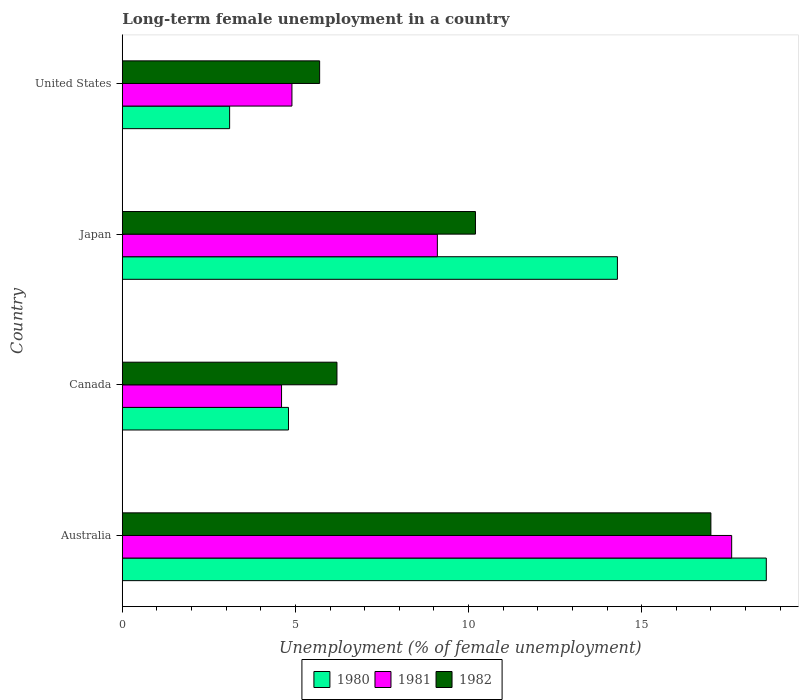How many different coloured bars are there?
Provide a succinct answer. 3. Are the number of bars per tick equal to the number of legend labels?
Ensure brevity in your answer.  Yes. How many bars are there on the 1st tick from the top?
Your response must be concise. 3. What is the label of the 4th group of bars from the top?
Provide a succinct answer. Australia. What is the percentage of long-term unemployed female population in 1980 in United States?
Your answer should be compact. 3.1. Across all countries, what is the maximum percentage of long-term unemployed female population in 1980?
Your answer should be compact. 18.6. Across all countries, what is the minimum percentage of long-term unemployed female population in 1982?
Your response must be concise. 5.7. What is the total percentage of long-term unemployed female population in 1981 in the graph?
Your response must be concise. 36.2. What is the difference between the percentage of long-term unemployed female population in 1980 in Japan and that in United States?
Keep it short and to the point. 11.2. What is the difference between the percentage of long-term unemployed female population in 1982 in Canada and the percentage of long-term unemployed female population in 1981 in Australia?
Your answer should be very brief. -11.4. What is the average percentage of long-term unemployed female population in 1980 per country?
Ensure brevity in your answer.  10.2. What is the difference between the percentage of long-term unemployed female population in 1980 and percentage of long-term unemployed female population in 1982 in United States?
Provide a short and direct response. -2.6. In how many countries, is the percentage of long-term unemployed female population in 1981 greater than 7 %?
Make the answer very short. 2. What is the ratio of the percentage of long-term unemployed female population in 1981 in Japan to that in United States?
Offer a very short reply. 1.86. What is the difference between the highest and the second highest percentage of long-term unemployed female population in 1980?
Provide a short and direct response. 4.3. What is the difference between the highest and the lowest percentage of long-term unemployed female population in 1980?
Keep it short and to the point. 15.5. Is the sum of the percentage of long-term unemployed female population in 1980 in Japan and United States greater than the maximum percentage of long-term unemployed female population in 1981 across all countries?
Offer a terse response. No. What does the 2nd bar from the bottom in Japan represents?
Your answer should be compact. 1981. How many bars are there?
Make the answer very short. 12. How many legend labels are there?
Ensure brevity in your answer.  3. What is the title of the graph?
Provide a short and direct response. Long-term female unemployment in a country. Does "1977" appear as one of the legend labels in the graph?
Make the answer very short. No. What is the label or title of the X-axis?
Make the answer very short. Unemployment (% of female unemployment). What is the label or title of the Y-axis?
Give a very brief answer. Country. What is the Unemployment (% of female unemployment) of 1980 in Australia?
Ensure brevity in your answer.  18.6. What is the Unemployment (% of female unemployment) of 1981 in Australia?
Your response must be concise. 17.6. What is the Unemployment (% of female unemployment) in 1982 in Australia?
Your answer should be compact. 17. What is the Unemployment (% of female unemployment) in 1980 in Canada?
Keep it short and to the point. 4.8. What is the Unemployment (% of female unemployment) of 1981 in Canada?
Give a very brief answer. 4.6. What is the Unemployment (% of female unemployment) of 1982 in Canada?
Offer a terse response. 6.2. What is the Unemployment (% of female unemployment) of 1980 in Japan?
Give a very brief answer. 14.3. What is the Unemployment (% of female unemployment) in 1981 in Japan?
Keep it short and to the point. 9.1. What is the Unemployment (% of female unemployment) in 1982 in Japan?
Keep it short and to the point. 10.2. What is the Unemployment (% of female unemployment) in 1980 in United States?
Provide a short and direct response. 3.1. What is the Unemployment (% of female unemployment) of 1981 in United States?
Ensure brevity in your answer.  4.9. What is the Unemployment (% of female unemployment) in 1982 in United States?
Offer a terse response. 5.7. Across all countries, what is the maximum Unemployment (% of female unemployment) in 1980?
Ensure brevity in your answer.  18.6. Across all countries, what is the maximum Unemployment (% of female unemployment) in 1981?
Keep it short and to the point. 17.6. Across all countries, what is the minimum Unemployment (% of female unemployment) of 1980?
Offer a very short reply. 3.1. Across all countries, what is the minimum Unemployment (% of female unemployment) of 1981?
Give a very brief answer. 4.6. Across all countries, what is the minimum Unemployment (% of female unemployment) of 1982?
Make the answer very short. 5.7. What is the total Unemployment (% of female unemployment) of 1980 in the graph?
Keep it short and to the point. 40.8. What is the total Unemployment (% of female unemployment) in 1981 in the graph?
Make the answer very short. 36.2. What is the total Unemployment (% of female unemployment) of 1982 in the graph?
Provide a succinct answer. 39.1. What is the difference between the Unemployment (% of female unemployment) of 1981 in Australia and that in Canada?
Offer a terse response. 13. What is the difference between the Unemployment (% of female unemployment) in 1982 in Australia and that in Canada?
Provide a short and direct response. 10.8. What is the difference between the Unemployment (% of female unemployment) of 1980 in Australia and that in Japan?
Provide a succinct answer. 4.3. What is the difference between the Unemployment (% of female unemployment) in 1982 in Australia and that in United States?
Make the answer very short. 11.3. What is the difference between the Unemployment (% of female unemployment) of 1980 in Canada and that in Japan?
Your answer should be compact. -9.5. What is the difference between the Unemployment (% of female unemployment) of 1981 in Canada and that in Japan?
Your answer should be compact. -4.5. What is the difference between the Unemployment (% of female unemployment) of 1981 in Canada and that in United States?
Offer a terse response. -0.3. What is the difference between the Unemployment (% of female unemployment) of 1980 in Japan and that in United States?
Offer a terse response. 11.2. What is the difference between the Unemployment (% of female unemployment) of 1980 in Australia and the Unemployment (% of female unemployment) of 1981 in Canada?
Provide a short and direct response. 14. What is the difference between the Unemployment (% of female unemployment) in 1981 in Australia and the Unemployment (% of female unemployment) in 1982 in Canada?
Ensure brevity in your answer.  11.4. What is the difference between the Unemployment (% of female unemployment) in 1980 in Australia and the Unemployment (% of female unemployment) in 1981 in Japan?
Offer a very short reply. 9.5. What is the difference between the Unemployment (% of female unemployment) in 1981 in Australia and the Unemployment (% of female unemployment) in 1982 in Japan?
Keep it short and to the point. 7.4. What is the difference between the Unemployment (% of female unemployment) in 1980 in Australia and the Unemployment (% of female unemployment) in 1981 in United States?
Your answer should be very brief. 13.7. What is the difference between the Unemployment (% of female unemployment) in 1980 in Australia and the Unemployment (% of female unemployment) in 1982 in United States?
Your answer should be very brief. 12.9. What is the difference between the Unemployment (% of female unemployment) in 1980 in Canada and the Unemployment (% of female unemployment) in 1982 in Japan?
Your answer should be very brief. -5.4. What is the difference between the Unemployment (% of female unemployment) of 1981 in Canada and the Unemployment (% of female unemployment) of 1982 in Japan?
Ensure brevity in your answer.  -5.6. What is the difference between the Unemployment (% of female unemployment) in 1980 in Canada and the Unemployment (% of female unemployment) in 1981 in United States?
Make the answer very short. -0.1. What is the difference between the Unemployment (% of female unemployment) in 1980 in Canada and the Unemployment (% of female unemployment) in 1982 in United States?
Offer a very short reply. -0.9. What is the difference between the Unemployment (% of female unemployment) in 1980 in Japan and the Unemployment (% of female unemployment) in 1982 in United States?
Offer a very short reply. 8.6. What is the difference between the Unemployment (% of female unemployment) of 1981 in Japan and the Unemployment (% of female unemployment) of 1982 in United States?
Provide a succinct answer. 3.4. What is the average Unemployment (% of female unemployment) in 1980 per country?
Offer a very short reply. 10.2. What is the average Unemployment (% of female unemployment) of 1981 per country?
Give a very brief answer. 9.05. What is the average Unemployment (% of female unemployment) in 1982 per country?
Ensure brevity in your answer.  9.78. What is the difference between the Unemployment (% of female unemployment) of 1980 and Unemployment (% of female unemployment) of 1981 in Australia?
Your response must be concise. 1. What is the difference between the Unemployment (% of female unemployment) in 1980 and Unemployment (% of female unemployment) in 1982 in Australia?
Offer a terse response. 1.6. What is the difference between the Unemployment (% of female unemployment) of 1981 and Unemployment (% of female unemployment) of 1982 in Australia?
Keep it short and to the point. 0.6. What is the difference between the Unemployment (% of female unemployment) of 1980 and Unemployment (% of female unemployment) of 1982 in Japan?
Your response must be concise. 4.1. What is the difference between the Unemployment (% of female unemployment) of 1981 and Unemployment (% of female unemployment) of 1982 in Japan?
Offer a very short reply. -1.1. What is the difference between the Unemployment (% of female unemployment) in 1980 and Unemployment (% of female unemployment) in 1982 in United States?
Make the answer very short. -2.6. What is the difference between the Unemployment (% of female unemployment) in 1981 and Unemployment (% of female unemployment) in 1982 in United States?
Make the answer very short. -0.8. What is the ratio of the Unemployment (% of female unemployment) of 1980 in Australia to that in Canada?
Your answer should be compact. 3.88. What is the ratio of the Unemployment (% of female unemployment) in 1981 in Australia to that in Canada?
Keep it short and to the point. 3.83. What is the ratio of the Unemployment (% of female unemployment) of 1982 in Australia to that in Canada?
Make the answer very short. 2.74. What is the ratio of the Unemployment (% of female unemployment) in 1980 in Australia to that in Japan?
Offer a very short reply. 1.3. What is the ratio of the Unemployment (% of female unemployment) in 1981 in Australia to that in Japan?
Ensure brevity in your answer.  1.93. What is the ratio of the Unemployment (% of female unemployment) of 1980 in Australia to that in United States?
Make the answer very short. 6. What is the ratio of the Unemployment (% of female unemployment) of 1981 in Australia to that in United States?
Your answer should be compact. 3.59. What is the ratio of the Unemployment (% of female unemployment) in 1982 in Australia to that in United States?
Keep it short and to the point. 2.98. What is the ratio of the Unemployment (% of female unemployment) of 1980 in Canada to that in Japan?
Make the answer very short. 0.34. What is the ratio of the Unemployment (% of female unemployment) of 1981 in Canada to that in Japan?
Make the answer very short. 0.51. What is the ratio of the Unemployment (% of female unemployment) of 1982 in Canada to that in Japan?
Offer a terse response. 0.61. What is the ratio of the Unemployment (% of female unemployment) of 1980 in Canada to that in United States?
Ensure brevity in your answer.  1.55. What is the ratio of the Unemployment (% of female unemployment) in 1981 in Canada to that in United States?
Give a very brief answer. 0.94. What is the ratio of the Unemployment (% of female unemployment) of 1982 in Canada to that in United States?
Give a very brief answer. 1.09. What is the ratio of the Unemployment (% of female unemployment) in 1980 in Japan to that in United States?
Ensure brevity in your answer.  4.61. What is the ratio of the Unemployment (% of female unemployment) in 1981 in Japan to that in United States?
Give a very brief answer. 1.86. What is the ratio of the Unemployment (% of female unemployment) in 1982 in Japan to that in United States?
Provide a short and direct response. 1.79. What is the difference between the highest and the second highest Unemployment (% of female unemployment) in 1980?
Offer a very short reply. 4.3. What is the difference between the highest and the second highest Unemployment (% of female unemployment) of 1981?
Provide a succinct answer. 8.5. What is the difference between the highest and the second highest Unemployment (% of female unemployment) of 1982?
Provide a succinct answer. 6.8. What is the difference between the highest and the lowest Unemployment (% of female unemployment) in 1981?
Provide a short and direct response. 13. What is the difference between the highest and the lowest Unemployment (% of female unemployment) in 1982?
Ensure brevity in your answer.  11.3. 